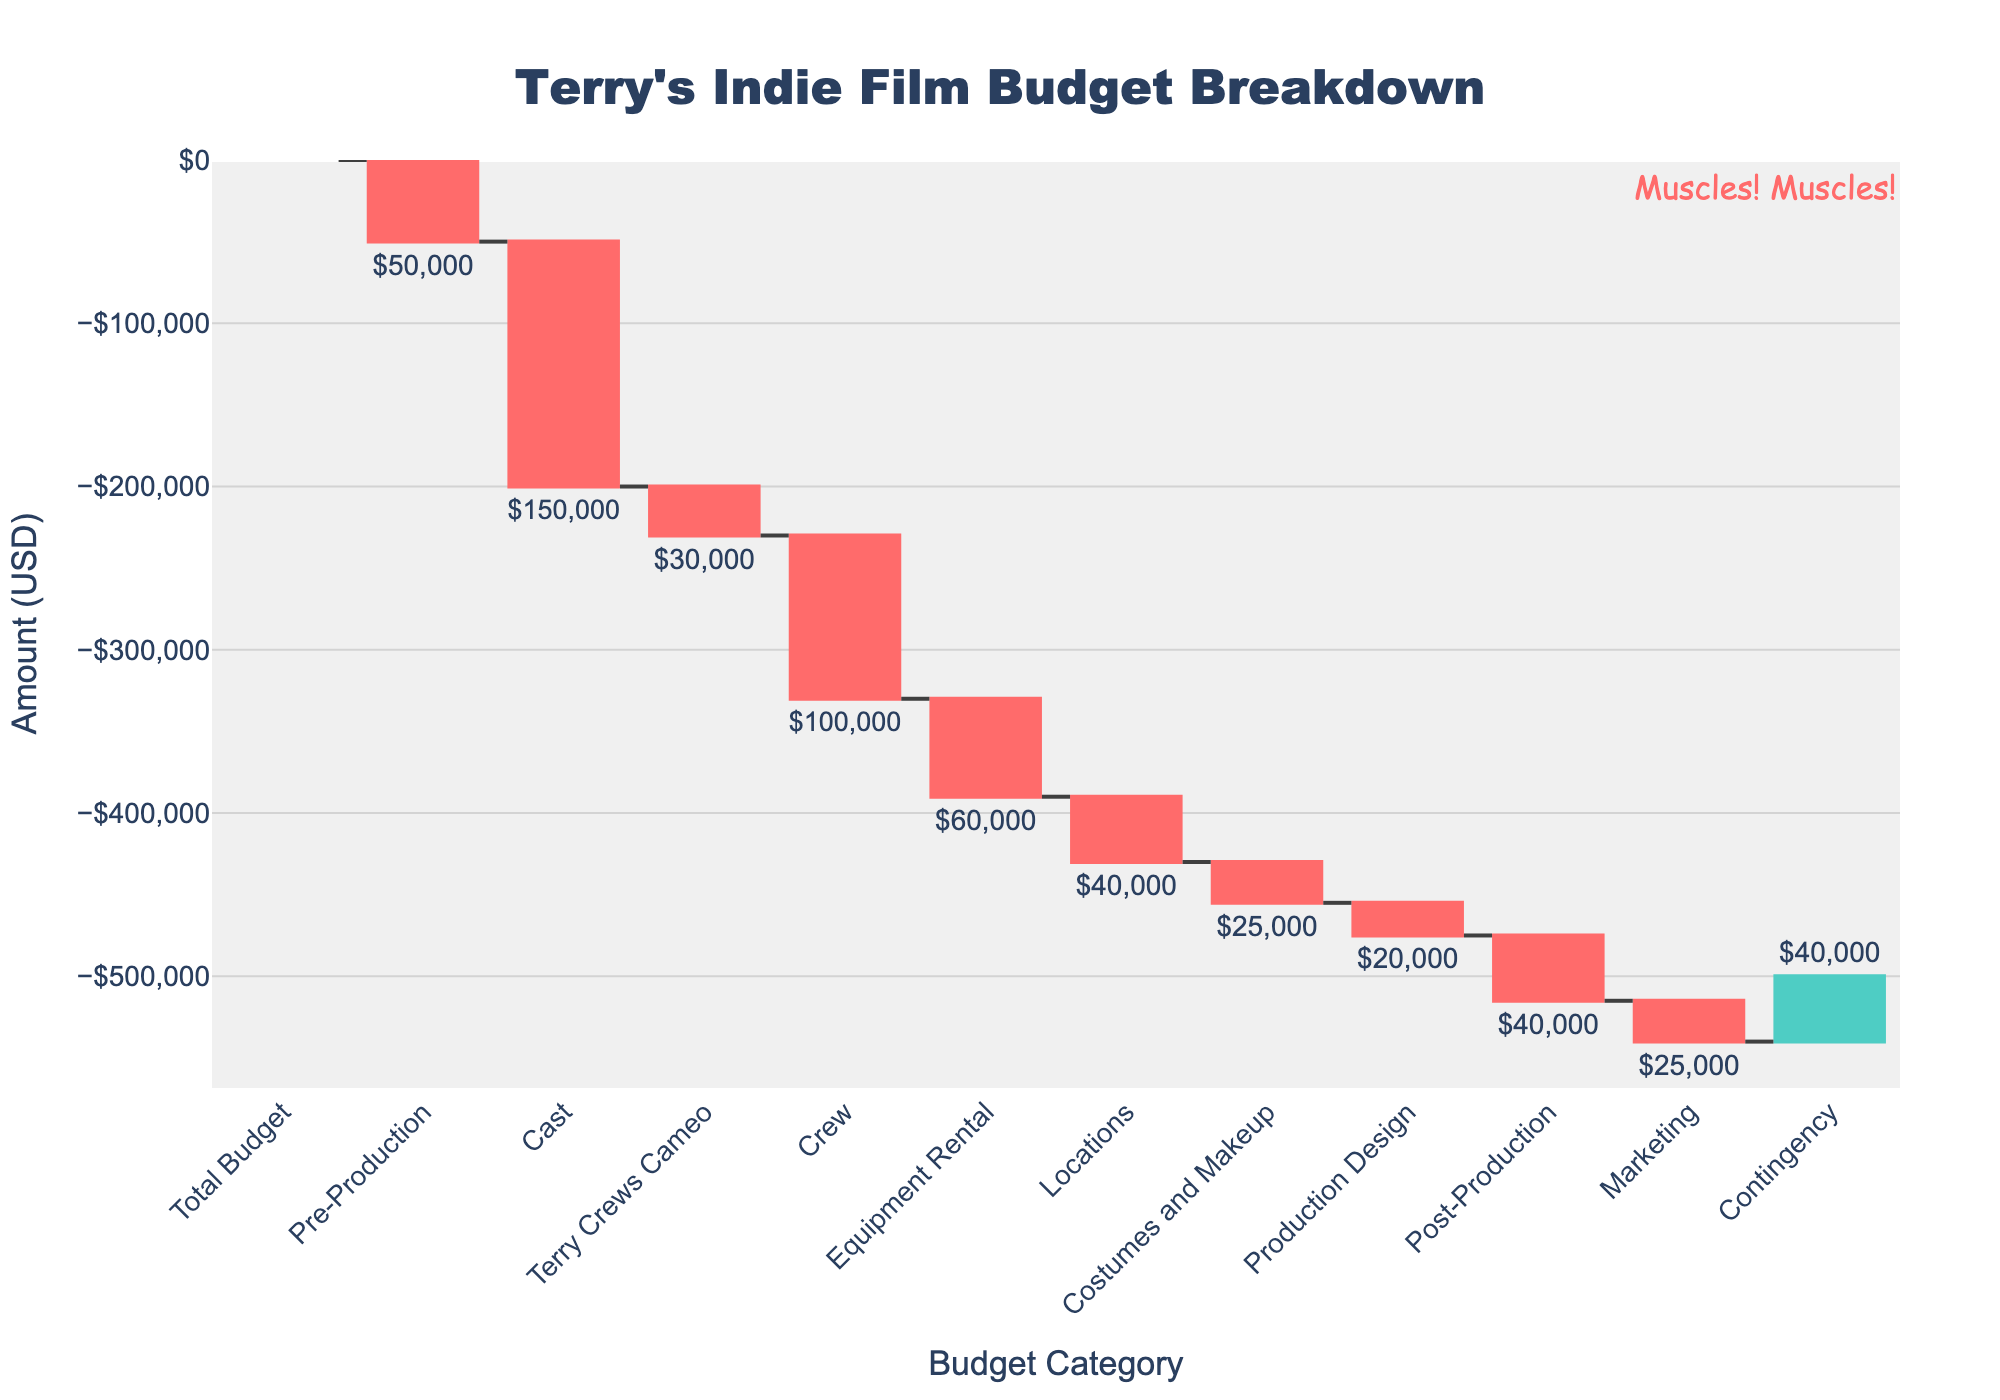Which category has the highest expense allocation? The highest expense allocation is identified through the largest negative bar value in the Waterfall Chart. The "Cast" category has the largest drop, indicating the highest expense allocation.
Answer: Cast What's the total amount allocated for Terry Crews' cameo appearance? The Waterfall Chart shows the "Terry Crews Cameo" value as one of the categories. This value is represented as a negative figure. The total amount allocated is listed next to the bar labeled "Terry Crews Cameo".
Answer: $30,000 What's the remaining budget after accounting for Pre-Production and Cast expenses? To find the remaining budget after the Pre-Production and Cast expenses, subtract the combined expenses of these categories from the Total Budget. This means $500,000 - $50,000 (Pre-Production) - $150,000 (Cast).
Answer: $300,000 How much is allocated for both Crew and Equipment Rental combined? To find the combined allocation for Crew and Equipment Rental, add the expenses for both categories together. Subtract $100,000 (Crew) + $60,000 (Equipment Rental) from $0.
Answer: $160,000 Which category contributes positively to the budget, and how much is the contribution? Positive contributions in a Waterfall Chart are represented by bars going upwards. "Contingency" is the category that contributes positively, as its bar goes upwards on the Waterfall Chart.
Answer: $40,000 How much is allocated in total for Production-related expenses (including Equipment Rental and Locations)? To find the total production-related expenses, add the values for Equipment Rental and Locations. Therefore, subtract $60,000 (Equipment Rental) + $40,000 (Locations) from $0.
Answer: $100,000 Which category has the smallest expense allocation? The smallest expense allocation can be identified as the category with the smallest negative bar value. "Production Design" has the smallest value allocated for budget.
Answer: Production Design What's the net allocation for Post-Production and Marketing combined? To find the net allocation for Post-Production and Marketing combined, add the expenses for both categories together. Subtract $40,000 (Post-Production) + $25,000 (Marketing) from $0.
Answer: $65,000 Is the budget for the Cast larger than the combined budgets for Pre-Production and Costumes and Makeup? To determine this, compare the values. The Cast budget is $150,000, and the combined total for Pre-Production and Costumes and Makeup is $50,000 (Pre-Production) + $25,000 (Costumes and Makeup) = $75,000. Since $150,000 > $75,000, the Cast budget is indeed larger.
Answer: Yes What's the total of negative allocations, excluding the "Contingency"? To calculate the total expenses excluding the positive "Contingency", add up all the negative values: $50,000 (Pre-Production) + $150,000 (Cast) + $30,000 (Terry Crews Cameo) + $100,000 (Crew) + $60,000 (Equipment Rental) + $40,000 (Locations) + $25,000 (Costumes and Makeup) + $20,000 (Production Design) + $40,000 (Post-Production) + $25,000 (Marketing).
Answer: $540,000 